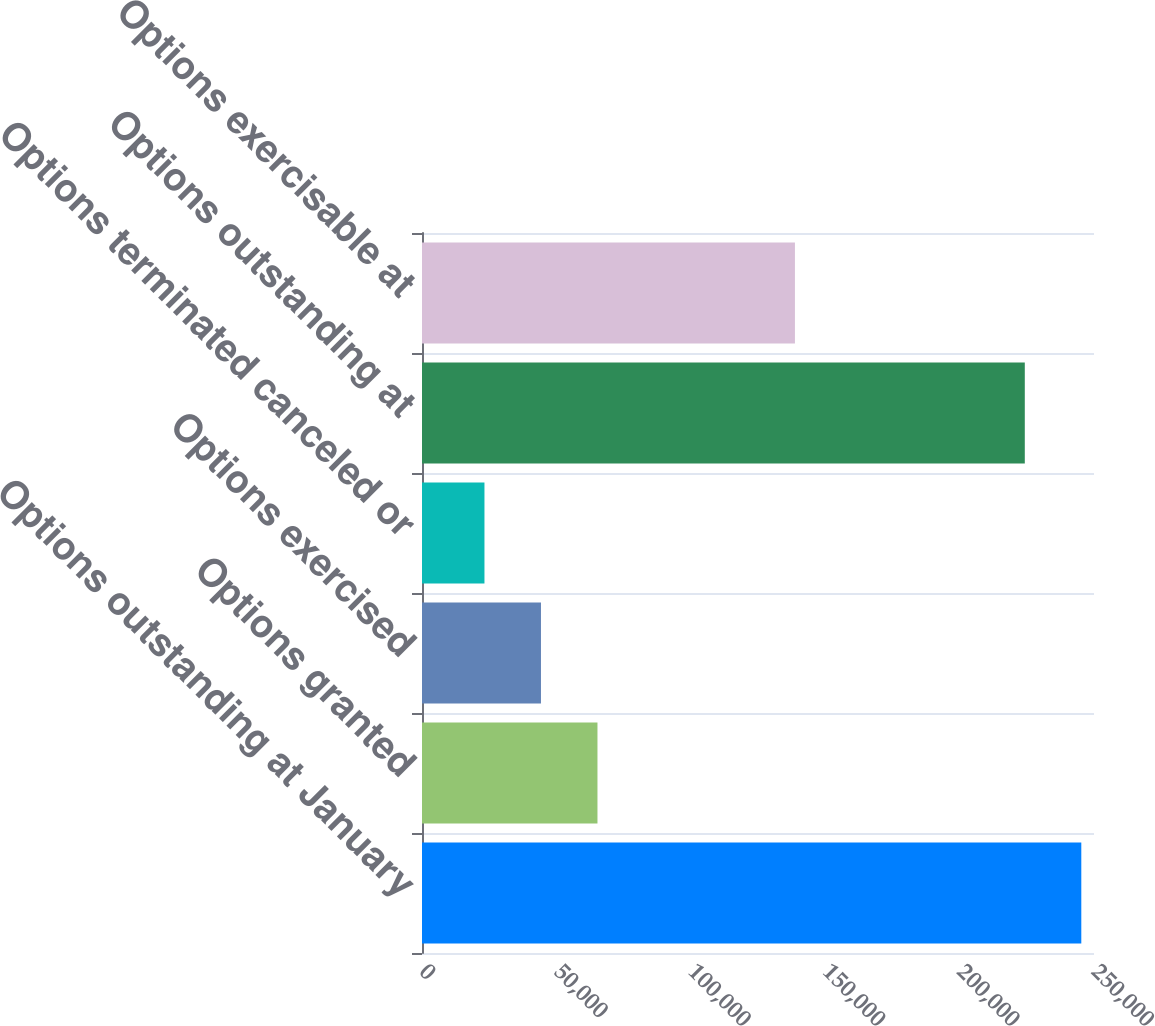Convert chart. <chart><loc_0><loc_0><loc_500><loc_500><bar_chart><fcel>Options outstanding at January<fcel>Options granted<fcel>Options exercised<fcel>Options terminated canceled or<fcel>Options outstanding at<fcel>Options exercisable at<nl><fcel>245276<fcel>65277.8<fcel>44256.9<fcel>23236<fcel>224255<fcel>138741<nl></chart> 